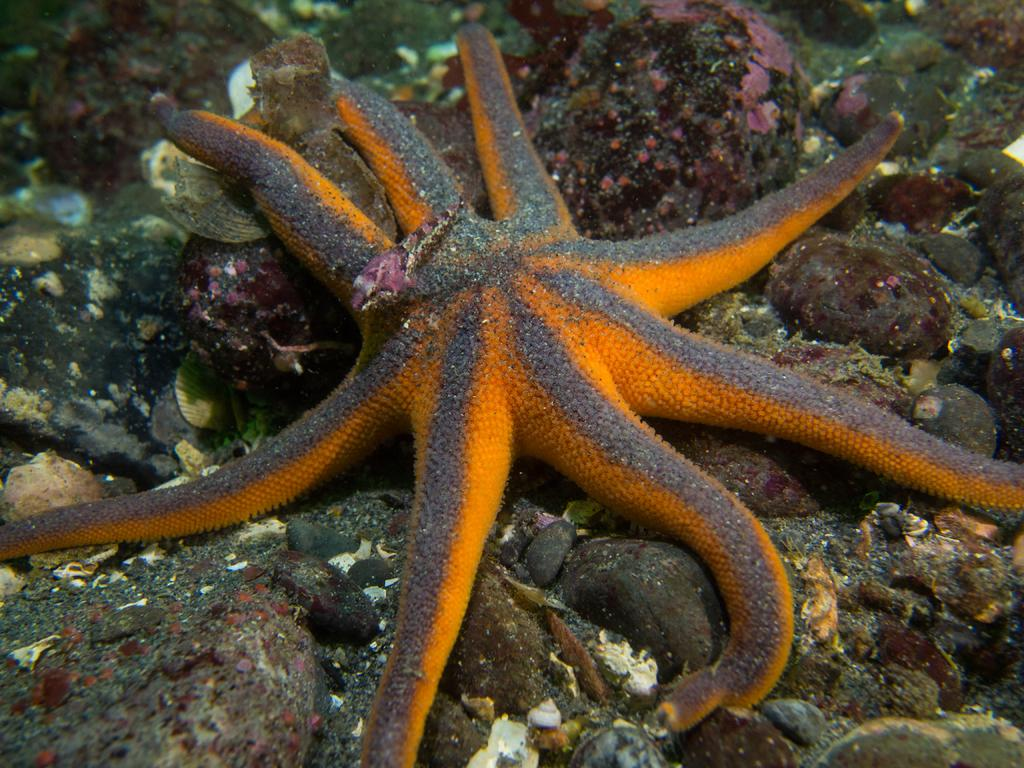What type of animal is in the image? There is a starfish in the image. What is the starfish doing in the image? The starfish is standing on the ground. What type of knee injury can be seen on the starfish in the image? There is no knee injury present on the starfish in the image, as starfish do not have knees. 